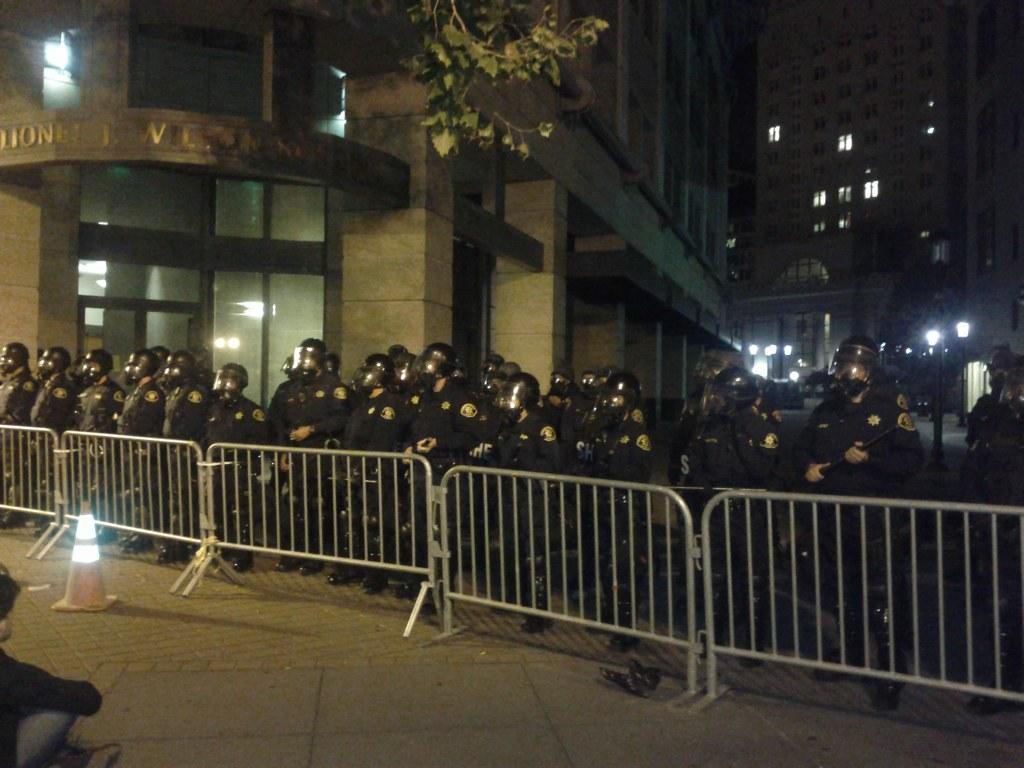In one or two sentences, can you explain what this image depicts? Here we can see group of people, fence, traffic cone, poles, lights, and leaves. In the background there are buildings. 